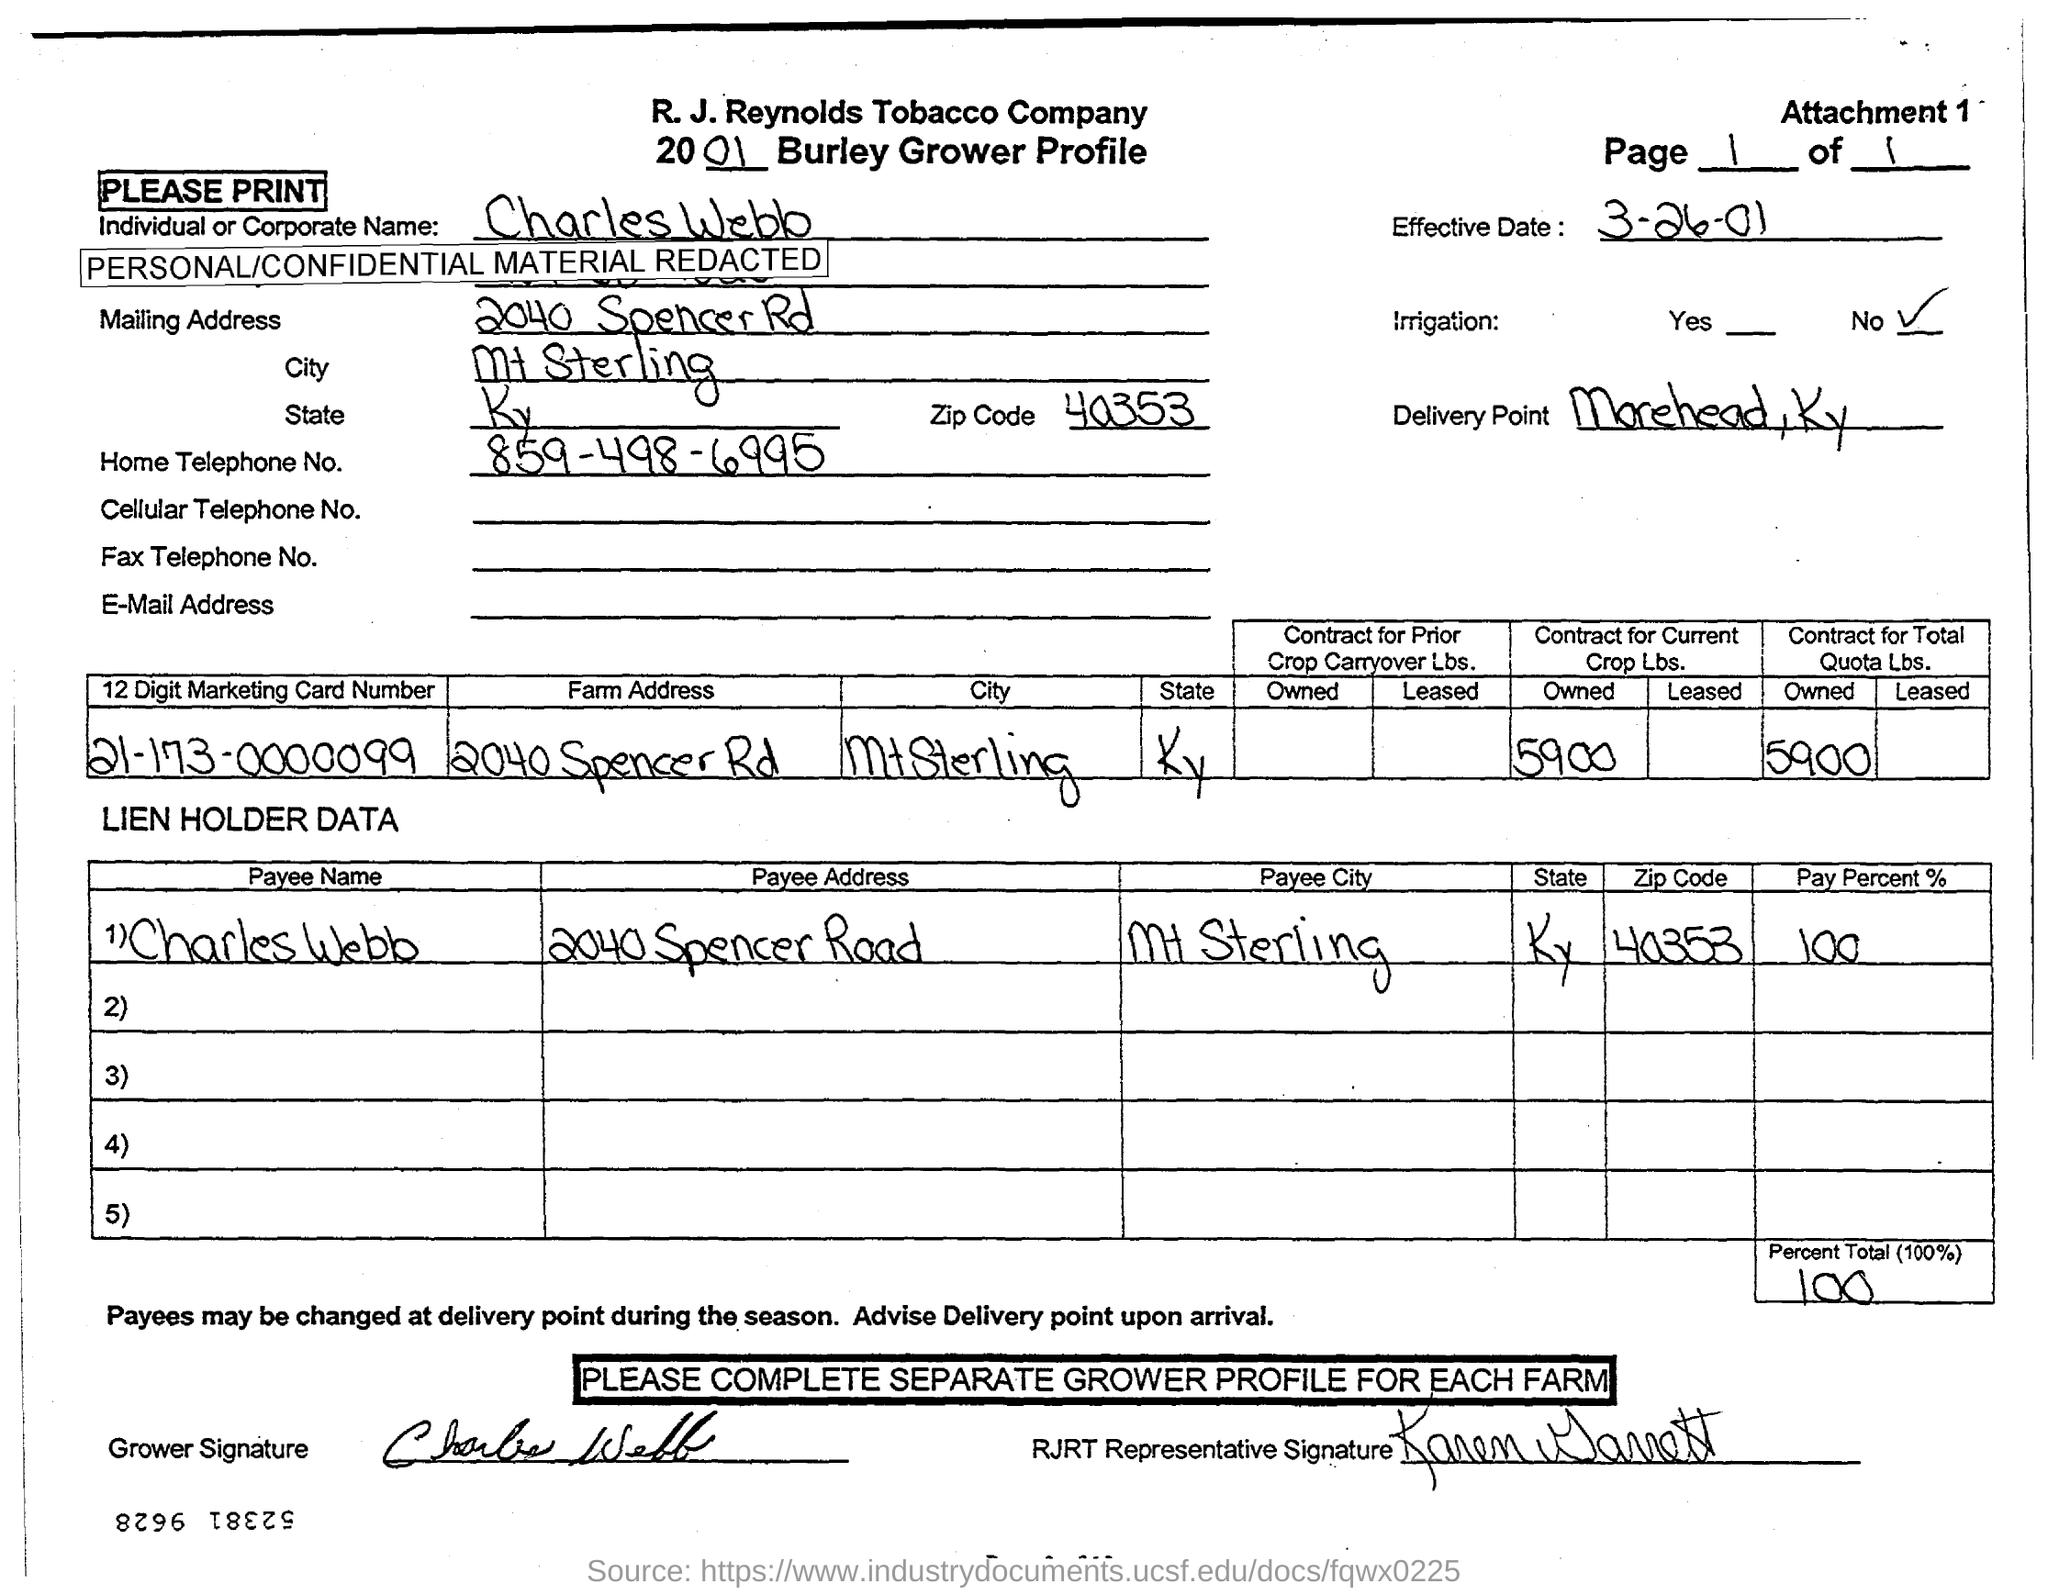What is the "Payee Name"?
Your response must be concise. Charles Webb. What is the "Payee Address"?
Make the answer very short. 2040 Spencer Road. What is the Home Telephone Number?
Give a very brief answer. 859-498-6995. What is the City?
Make the answer very short. Mt Sterling. 